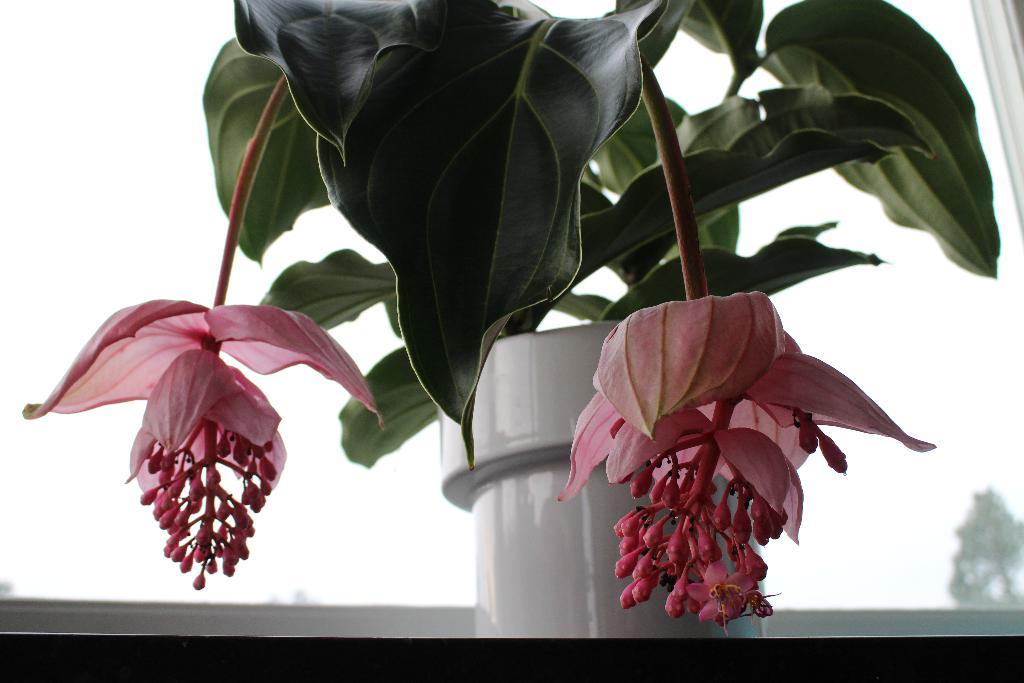What type of plant can be seen in the image? There is a plant with flowers in the image. How is the plant contained or displayed? The plant is in a pot. What can be seen in the background of the image? There is a window visible in the background of the image. What type of hat is the plant wearing in the image? There is no hat present on the plant in the image. How does the ground look like in the image? The ground is not visible in the image; only the plant, the pot, and the window are present. 